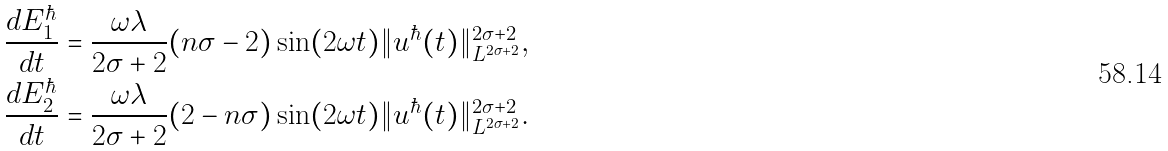<formula> <loc_0><loc_0><loc_500><loc_500>\frac { d E _ { 1 } ^ { \hbar } } { d t } & = \frac { \omega \lambda } { 2 \sigma + 2 } ( n \sigma - 2 ) \sin ( 2 \omega t ) \| u ^ { \hbar } ( t ) \| _ { L ^ { 2 \sigma + 2 } } ^ { 2 \sigma + 2 } , \\ \frac { d E _ { 2 } ^ { \hbar } } { d t } & = \frac { \omega \lambda } { 2 \sigma + 2 } ( 2 - n \sigma ) \sin ( 2 \omega t ) \| u ^ { \hbar } ( t ) \| _ { L ^ { 2 \sigma + 2 } } ^ { 2 \sigma + 2 } .</formula> 